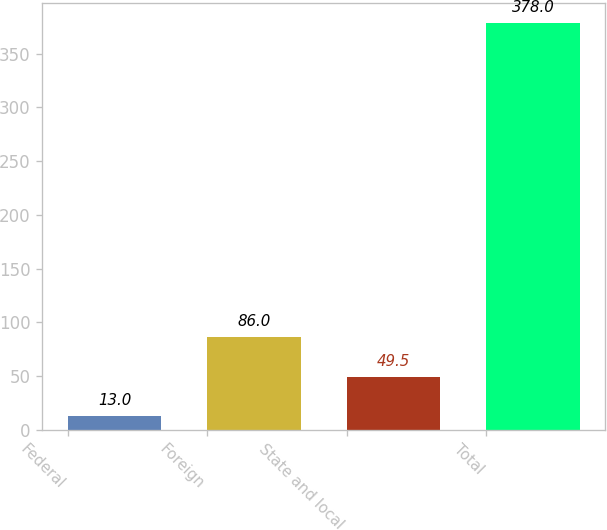<chart> <loc_0><loc_0><loc_500><loc_500><bar_chart><fcel>Federal<fcel>Foreign<fcel>State and local<fcel>Total<nl><fcel>13<fcel>86<fcel>49.5<fcel>378<nl></chart> 